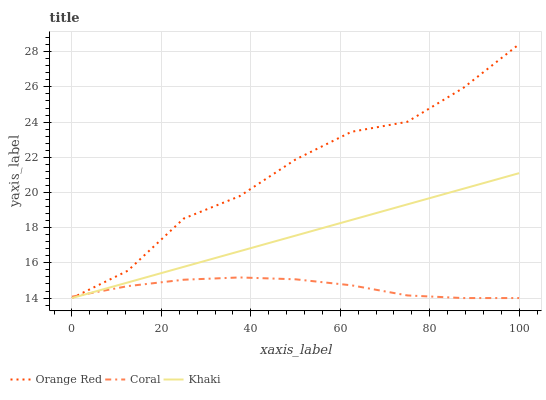Does Coral have the minimum area under the curve?
Answer yes or no. Yes. Does Orange Red have the maximum area under the curve?
Answer yes or no. Yes. Does Khaki have the minimum area under the curve?
Answer yes or no. No. Does Khaki have the maximum area under the curve?
Answer yes or no. No. Is Khaki the smoothest?
Answer yes or no. Yes. Is Orange Red the roughest?
Answer yes or no. Yes. Is Orange Red the smoothest?
Answer yes or no. No. Is Khaki the roughest?
Answer yes or no. No. Does Coral have the lowest value?
Answer yes or no. Yes. Does Orange Red have the highest value?
Answer yes or no. Yes. Does Khaki have the highest value?
Answer yes or no. No. Does Coral intersect Orange Red?
Answer yes or no. Yes. Is Coral less than Orange Red?
Answer yes or no. No. Is Coral greater than Orange Red?
Answer yes or no. No. 